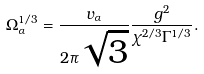<formula> <loc_0><loc_0><loc_500><loc_500>\Omega _ { \alpha } ^ { 1 / 3 } = \frac { v _ { \alpha } } { 2 \pi \sqrt { 3 } } \frac { g ^ { 2 } } { \chi ^ { 2 / 3 } \Gamma ^ { 1 / 3 } } .</formula> 